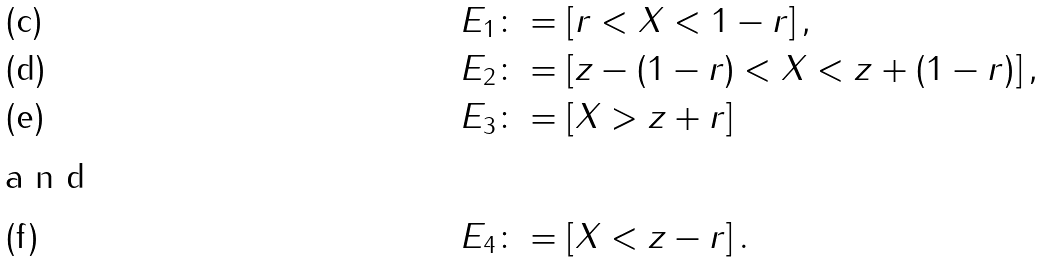<formula> <loc_0><loc_0><loc_500><loc_500>E _ { 1 } & \colon = \left [ r < X < 1 - r \right ] , \\ E _ { 2 } & \colon = \left [ z - ( 1 - r ) < X < z + ( 1 - r ) \right ] , \\ E _ { 3 } & \colon = \left [ X > z + r \right ] \\ \intertext { a n d } E _ { 4 } & \colon = \left [ X < z - r \right ] .</formula> 